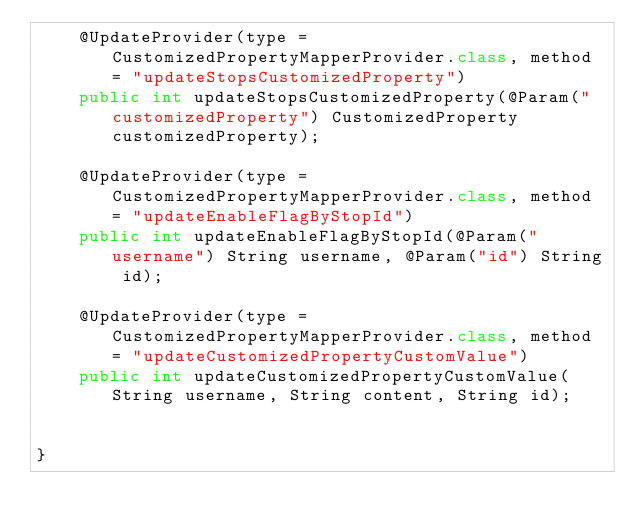<code> <loc_0><loc_0><loc_500><loc_500><_Java_>    @UpdateProvider(type = CustomizedPropertyMapperProvider.class, method = "updateStopsCustomizedProperty")
    public int updateStopsCustomizedProperty(@Param("customizedProperty") CustomizedProperty customizedProperty);

    @UpdateProvider(type = CustomizedPropertyMapperProvider.class, method = "updateEnableFlagByStopId")
    public int updateEnableFlagByStopId(@Param("username") String username, @Param("id") String id);

    @UpdateProvider(type = CustomizedPropertyMapperProvider.class, method = "updateCustomizedPropertyCustomValue")
    public int updateCustomizedPropertyCustomValue(String username, String content, String id);


}
</code> 